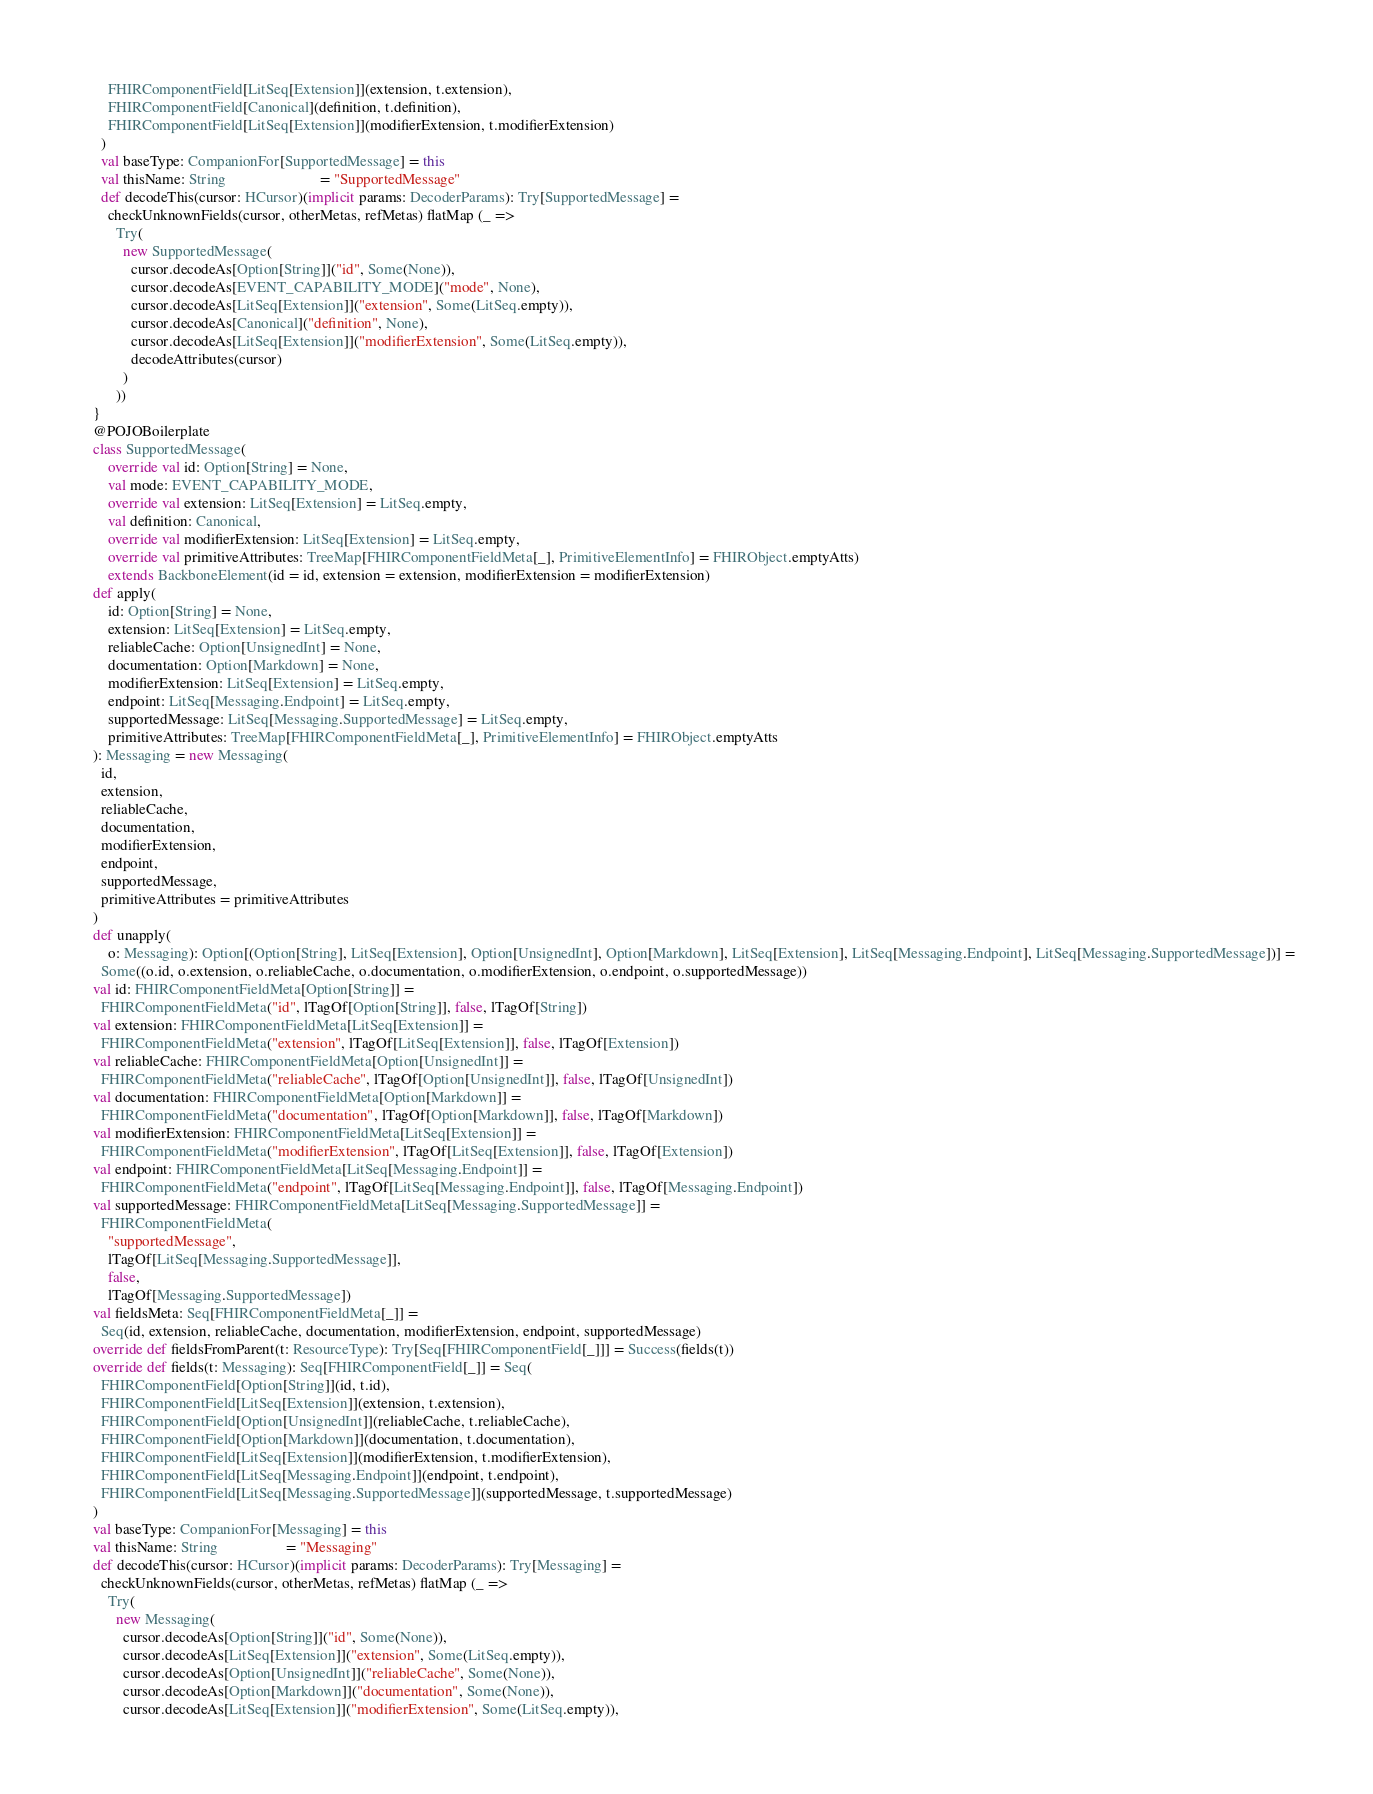<code> <loc_0><loc_0><loc_500><loc_500><_Scala_>        FHIRComponentField[LitSeq[Extension]](extension, t.extension),
        FHIRComponentField[Canonical](definition, t.definition),
        FHIRComponentField[LitSeq[Extension]](modifierExtension, t.modifierExtension)
      )
      val baseType: CompanionFor[SupportedMessage] = this
      val thisName: String                         = "SupportedMessage"
      def decodeThis(cursor: HCursor)(implicit params: DecoderParams): Try[SupportedMessage] =
        checkUnknownFields(cursor, otherMetas, refMetas) flatMap (_ =>
          Try(
            new SupportedMessage(
              cursor.decodeAs[Option[String]]("id", Some(None)),
              cursor.decodeAs[EVENT_CAPABILITY_MODE]("mode", None),
              cursor.decodeAs[LitSeq[Extension]]("extension", Some(LitSeq.empty)),
              cursor.decodeAs[Canonical]("definition", None),
              cursor.decodeAs[LitSeq[Extension]]("modifierExtension", Some(LitSeq.empty)),
              decodeAttributes(cursor)
            )
          ))
    }
    @POJOBoilerplate
    class SupportedMessage(
        override val id: Option[String] = None,
        val mode: EVENT_CAPABILITY_MODE,
        override val extension: LitSeq[Extension] = LitSeq.empty,
        val definition: Canonical,
        override val modifierExtension: LitSeq[Extension] = LitSeq.empty,
        override val primitiveAttributes: TreeMap[FHIRComponentFieldMeta[_], PrimitiveElementInfo] = FHIRObject.emptyAtts)
        extends BackboneElement(id = id, extension = extension, modifierExtension = modifierExtension)
    def apply(
        id: Option[String] = None,
        extension: LitSeq[Extension] = LitSeq.empty,
        reliableCache: Option[UnsignedInt] = None,
        documentation: Option[Markdown] = None,
        modifierExtension: LitSeq[Extension] = LitSeq.empty,
        endpoint: LitSeq[Messaging.Endpoint] = LitSeq.empty,
        supportedMessage: LitSeq[Messaging.SupportedMessage] = LitSeq.empty,
        primitiveAttributes: TreeMap[FHIRComponentFieldMeta[_], PrimitiveElementInfo] = FHIRObject.emptyAtts
    ): Messaging = new Messaging(
      id,
      extension,
      reliableCache,
      documentation,
      modifierExtension,
      endpoint,
      supportedMessage,
      primitiveAttributes = primitiveAttributes
    )
    def unapply(
        o: Messaging): Option[(Option[String], LitSeq[Extension], Option[UnsignedInt], Option[Markdown], LitSeq[Extension], LitSeq[Messaging.Endpoint], LitSeq[Messaging.SupportedMessage])] =
      Some((o.id, o.extension, o.reliableCache, o.documentation, o.modifierExtension, o.endpoint, o.supportedMessage))
    val id: FHIRComponentFieldMeta[Option[String]] =
      FHIRComponentFieldMeta("id", lTagOf[Option[String]], false, lTagOf[String])
    val extension: FHIRComponentFieldMeta[LitSeq[Extension]] =
      FHIRComponentFieldMeta("extension", lTagOf[LitSeq[Extension]], false, lTagOf[Extension])
    val reliableCache: FHIRComponentFieldMeta[Option[UnsignedInt]] =
      FHIRComponentFieldMeta("reliableCache", lTagOf[Option[UnsignedInt]], false, lTagOf[UnsignedInt])
    val documentation: FHIRComponentFieldMeta[Option[Markdown]] =
      FHIRComponentFieldMeta("documentation", lTagOf[Option[Markdown]], false, lTagOf[Markdown])
    val modifierExtension: FHIRComponentFieldMeta[LitSeq[Extension]] =
      FHIRComponentFieldMeta("modifierExtension", lTagOf[LitSeq[Extension]], false, lTagOf[Extension])
    val endpoint: FHIRComponentFieldMeta[LitSeq[Messaging.Endpoint]] =
      FHIRComponentFieldMeta("endpoint", lTagOf[LitSeq[Messaging.Endpoint]], false, lTagOf[Messaging.Endpoint])
    val supportedMessage: FHIRComponentFieldMeta[LitSeq[Messaging.SupportedMessage]] =
      FHIRComponentFieldMeta(
        "supportedMessage",
        lTagOf[LitSeq[Messaging.SupportedMessage]],
        false,
        lTagOf[Messaging.SupportedMessage])
    val fieldsMeta: Seq[FHIRComponentFieldMeta[_]] =
      Seq(id, extension, reliableCache, documentation, modifierExtension, endpoint, supportedMessage)
    override def fieldsFromParent(t: ResourceType): Try[Seq[FHIRComponentField[_]]] = Success(fields(t))
    override def fields(t: Messaging): Seq[FHIRComponentField[_]] = Seq(
      FHIRComponentField[Option[String]](id, t.id),
      FHIRComponentField[LitSeq[Extension]](extension, t.extension),
      FHIRComponentField[Option[UnsignedInt]](reliableCache, t.reliableCache),
      FHIRComponentField[Option[Markdown]](documentation, t.documentation),
      FHIRComponentField[LitSeq[Extension]](modifierExtension, t.modifierExtension),
      FHIRComponentField[LitSeq[Messaging.Endpoint]](endpoint, t.endpoint),
      FHIRComponentField[LitSeq[Messaging.SupportedMessage]](supportedMessage, t.supportedMessage)
    )
    val baseType: CompanionFor[Messaging] = this
    val thisName: String                  = "Messaging"
    def decodeThis(cursor: HCursor)(implicit params: DecoderParams): Try[Messaging] =
      checkUnknownFields(cursor, otherMetas, refMetas) flatMap (_ =>
        Try(
          new Messaging(
            cursor.decodeAs[Option[String]]("id", Some(None)),
            cursor.decodeAs[LitSeq[Extension]]("extension", Some(LitSeq.empty)),
            cursor.decodeAs[Option[UnsignedInt]]("reliableCache", Some(None)),
            cursor.decodeAs[Option[Markdown]]("documentation", Some(None)),
            cursor.decodeAs[LitSeq[Extension]]("modifierExtension", Some(LitSeq.empty)),</code> 